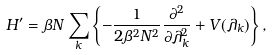<formula> <loc_0><loc_0><loc_500><loc_500>H ^ { \prime } = \beta N \sum _ { k } \left \{ - \frac { 1 } { 2 \beta ^ { 2 } N ^ { 2 } } \frac { \partial ^ { 2 } } { \partial \lambda _ { k } ^ { 2 } } + V ( \lambda _ { k } ) \right \} ,</formula> 